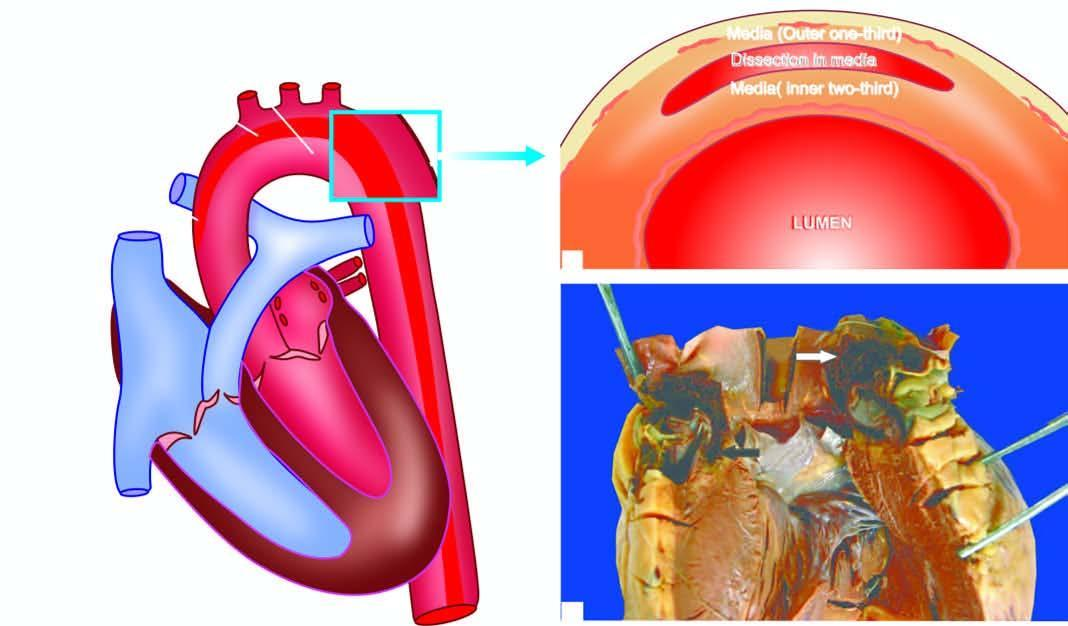s the particle an intimal tear in the aortic wall extending proximally upto aortic valve dissecting the media which contains clotted blood?
Answer the question using a single word or phrase. No 